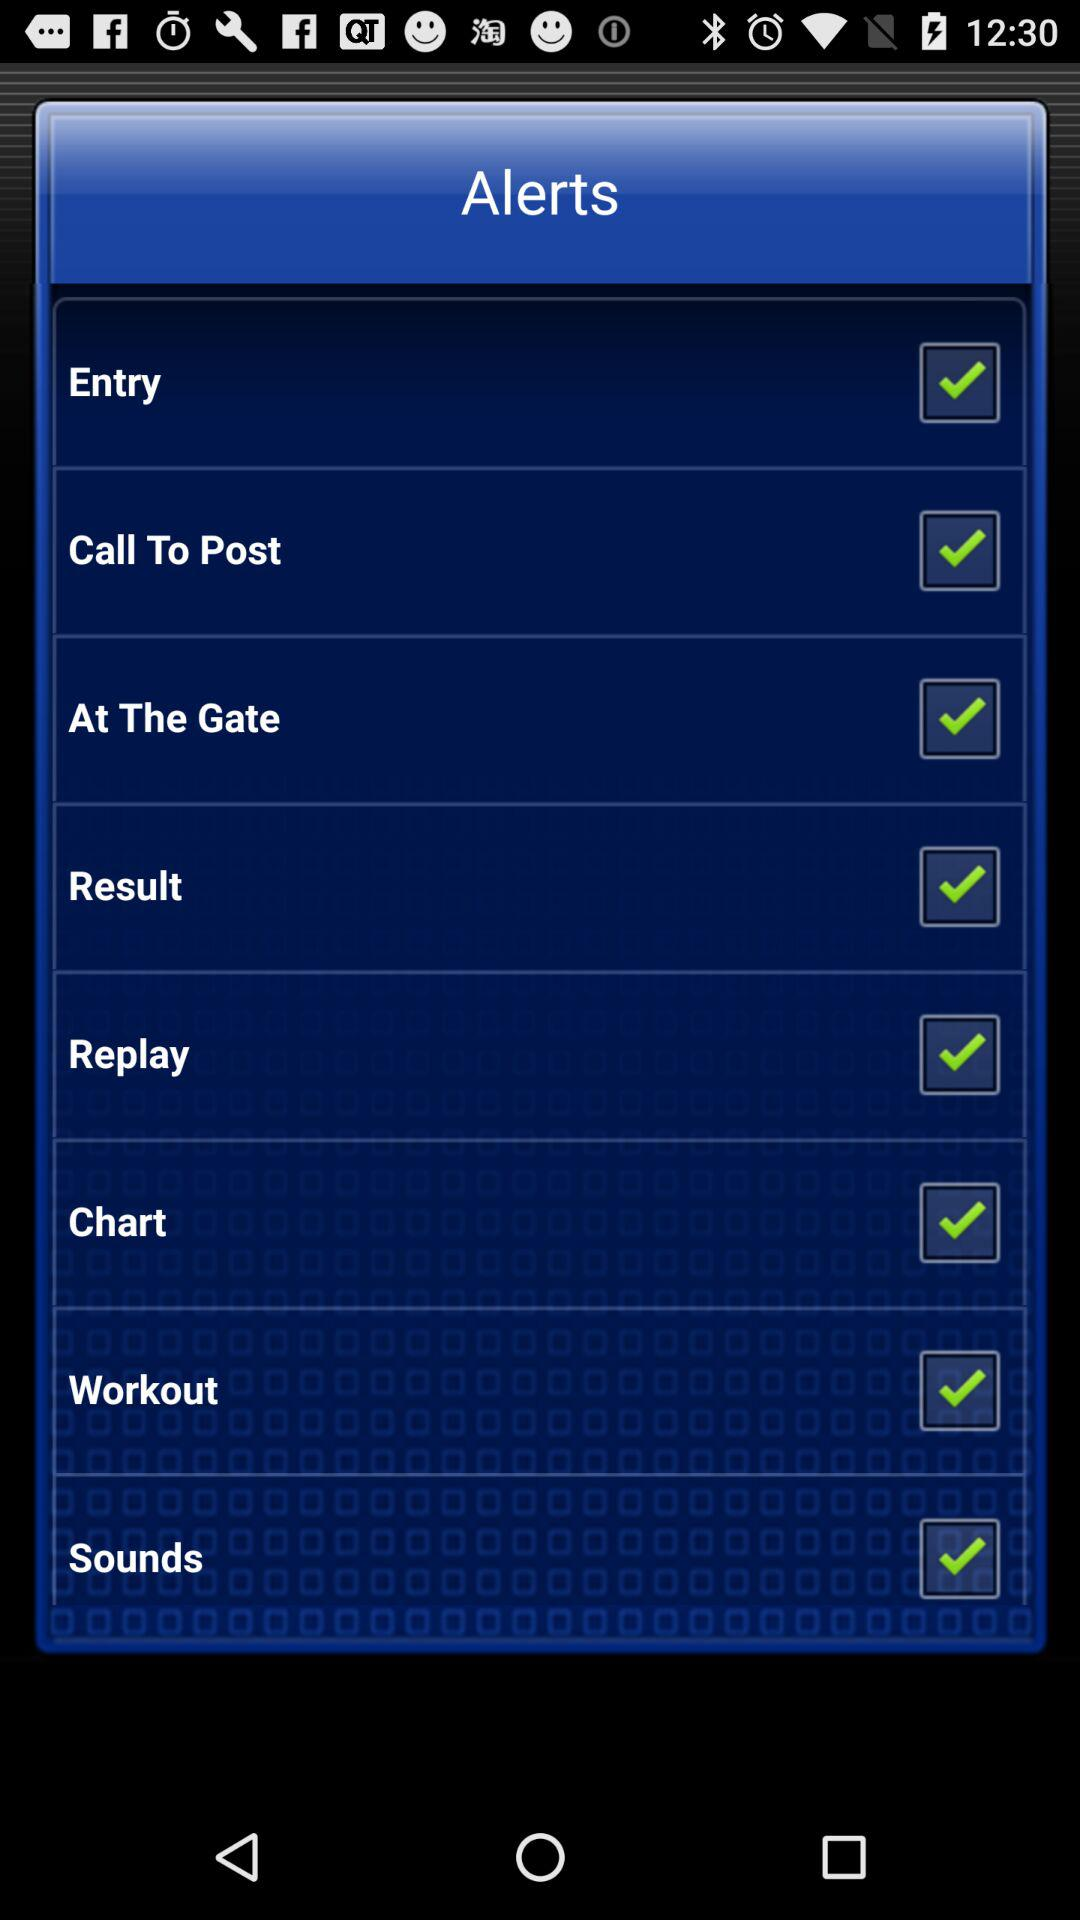What is the title? The title is "Alerts". 